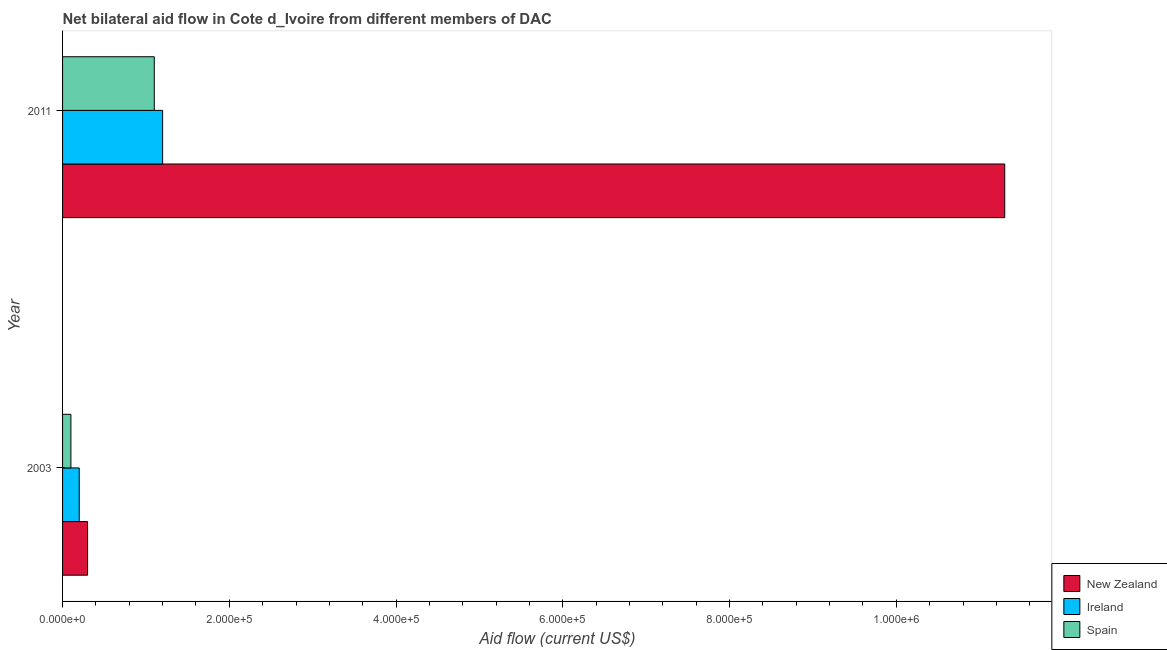How many groups of bars are there?
Your response must be concise. 2. Are the number of bars on each tick of the Y-axis equal?
Make the answer very short. Yes. What is the amount of aid provided by new zealand in 2011?
Offer a very short reply. 1.13e+06. Across all years, what is the maximum amount of aid provided by ireland?
Give a very brief answer. 1.20e+05. Across all years, what is the minimum amount of aid provided by new zealand?
Ensure brevity in your answer.  3.00e+04. In which year was the amount of aid provided by spain maximum?
Offer a very short reply. 2011. In which year was the amount of aid provided by ireland minimum?
Offer a terse response. 2003. What is the total amount of aid provided by ireland in the graph?
Ensure brevity in your answer.  1.40e+05. What is the difference between the amount of aid provided by ireland in 2003 and that in 2011?
Offer a terse response. -1.00e+05. What is the difference between the amount of aid provided by spain in 2003 and the amount of aid provided by ireland in 2011?
Make the answer very short. -1.10e+05. What is the average amount of aid provided by ireland per year?
Offer a terse response. 7.00e+04. In the year 2003, what is the difference between the amount of aid provided by new zealand and amount of aid provided by ireland?
Give a very brief answer. 10000. What is the ratio of the amount of aid provided by new zealand in 2003 to that in 2011?
Offer a very short reply. 0.03. Is the amount of aid provided by new zealand in 2003 less than that in 2011?
Offer a very short reply. Yes. Is the difference between the amount of aid provided by spain in 2003 and 2011 greater than the difference between the amount of aid provided by ireland in 2003 and 2011?
Your answer should be very brief. No. In how many years, is the amount of aid provided by new zealand greater than the average amount of aid provided by new zealand taken over all years?
Provide a short and direct response. 1. What does the 1st bar from the bottom in 2011 represents?
Offer a very short reply. New Zealand. Is it the case that in every year, the sum of the amount of aid provided by new zealand and amount of aid provided by ireland is greater than the amount of aid provided by spain?
Make the answer very short. Yes. How many bars are there?
Offer a very short reply. 6. Are all the bars in the graph horizontal?
Keep it short and to the point. Yes. What is the difference between two consecutive major ticks on the X-axis?
Provide a short and direct response. 2.00e+05. Are the values on the major ticks of X-axis written in scientific E-notation?
Make the answer very short. Yes. Does the graph contain any zero values?
Provide a short and direct response. No. Does the graph contain grids?
Your answer should be very brief. No. Where does the legend appear in the graph?
Your response must be concise. Bottom right. How many legend labels are there?
Your answer should be compact. 3. What is the title of the graph?
Ensure brevity in your answer.  Net bilateral aid flow in Cote d_Ivoire from different members of DAC. Does "Social Protection" appear as one of the legend labels in the graph?
Give a very brief answer. No. What is the label or title of the X-axis?
Your answer should be compact. Aid flow (current US$). What is the Aid flow (current US$) in New Zealand in 2003?
Your answer should be compact. 3.00e+04. What is the Aid flow (current US$) of New Zealand in 2011?
Give a very brief answer. 1.13e+06. What is the Aid flow (current US$) of Spain in 2011?
Keep it short and to the point. 1.10e+05. Across all years, what is the maximum Aid flow (current US$) in New Zealand?
Provide a short and direct response. 1.13e+06. Across all years, what is the minimum Aid flow (current US$) of Spain?
Provide a succinct answer. 10000. What is the total Aid flow (current US$) in New Zealand in the graph?
Your response must be concise. 1.16e+06. What is the total Aid flow (current US$) in Spain in the graph?
Your answer should be compact. 1.20e+05. What is the difference between the Aid flow (current US$) in New Zealand in 2003 and that in 2011?
Offer a very short reply. -1.10e+06. What is the average Aid flow (current US$) in New Zealand per year?
Your answer should be compact. 5.80e+05. What is the average Aid flow (current US$) of Ireland per year?
Your answer should be compact. 7.00e+04. In the year 2003, what is the difference between the Aid flow (current US$) in New Zealand and Aid flow (current US$) in Spain?
Make the answer very short. 2.00e+04. In the year 2003, what is the difference between the Aid flow (current US$) in Ireland and Aid flow (current US$) in Spain?
Offer a very short reply. 10000. In the year 2011, what is the difference between the Aid flow (current US$) in New Zealand and Aid flow (current US$) in Ireland?
Ensure brevity in your answer.  1.01e+06. In the year 2011, what is the difference between the Aid flow (current US$) in New Zealand and Aid flow (current US$) in Spain?
Your answer should be very brief. 1.02e+06. What is the ratio of the Aid flow (current US$) of New Zealand in 2003 to that in 2011?
Your answer should be compact. 0.03. What is the ratio of the Aid flow (current US$) of Spain in 2003 to that in 2011?
Your answer should be compact. 0.09. What is the difference between the highest and the second highest Aid flow (current US$) of New Zealand?
Offer a very short reply. 1.10e+06. What is the difference between the highest and the second highest Aid flow (current US$) of Ireland?
Provide a short and direct response. 1.00e+05. What is the difference between the highest and the second highest Aid flow (current US$) of Spain?
Offer a terse response. 1.00e+05. What is the difference between the highest and the lowest Aid flow (current US$) of New Zealand?
Offer a terse response. 1.10e+06. What is the difference between the highest and the lowest Aid flow (current US$) in Ireland?
Make the answer very short. 1.00e+05. 